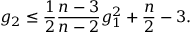Convert formula to latex. <formula><loc_0><loc_0><loc_500><loc_500>g _ { 2 } \leq { \frac { 1 } { 2 } } { \frac { n - 3 } { n - 2 } } g _ { 1 } ^ { 2 } + { \frac { n } { 2 } } - 3 .</formula> 